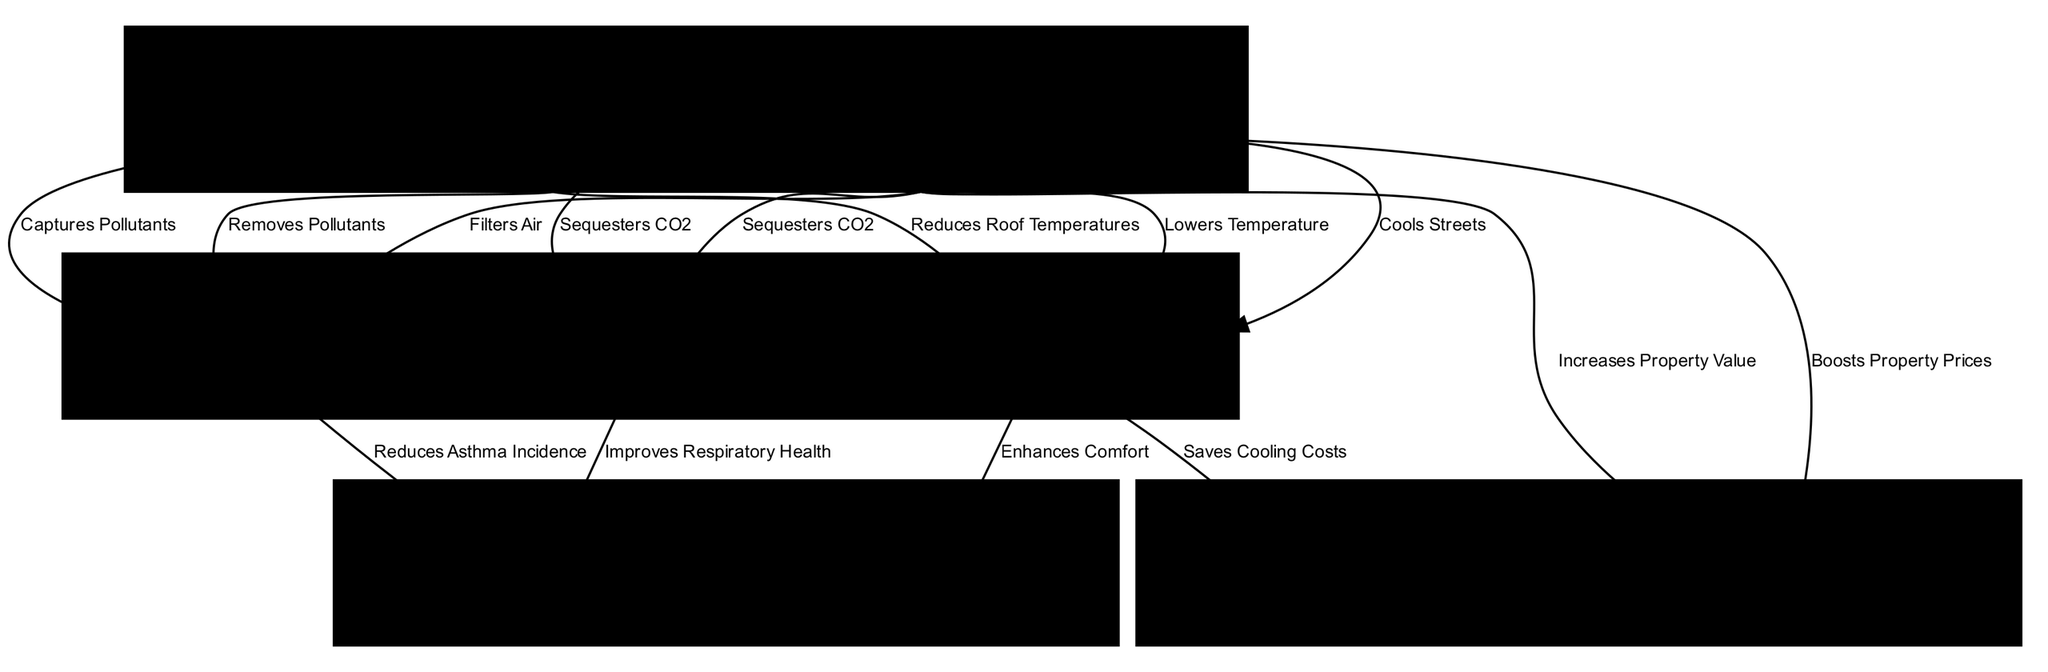What are the three types of green infrastructure elements listed? The diagram shows three types of green infrastructure elements: Urban Parks, Green Roofs, and Street Trees. This can be found in the "Green Infrastructure Elements" layer, where each element is represented as a node.
Answer: Urban Parks, Green Roofs, Street Trees How many environmental benefits are identified in the diagram? There are three environmental benefits detailed in the "Environmental Benefits" layer: CO2 Sequestration, Air Pollutant Removal, and Urban Heat Island Mitigation. Counting each node in this layer confirms the total.
Answer: Three Which green infrastructure element is associated with improving respiratory health? The Urban Parks node has a direct edge to the Respiratory Health node, indicating it contributes to improving respiratory health. By examining the connections between nodes, we identify this relationship.
Answer: Urban Parks What type of health impact is improved by mitigating urban heat islands? From the diagram, the Urban Heat Island Mitigation node connects to the Mental Well-being node, indicating that it enhances comfort, leading to improvements in mental health. This requires understanding the relationship between these two nodes.
Answer: Mental Well-being How many edges connect green infrastructure elements to environmental benefits? There are six edges connecting the green infrastructure elements to environmental benefits, as we can count the number of edges originating from the nodes in the "Green Infrastructure Elements" layer and leading to the "Environmental Benefits" layer.
Answer: Six Which green infrastructure element increases property values? Both the Urban Parks and Street Trees have edges pointing to the Increased Property Values node, indicating they contribute to boosting property prices. This requires looking at the edges connected to the property values node.
Answer: Urban Parks, Street Trees What is the economic benefit associated with healthcare cost savings? The Savings Cooling Costs node connects to the Healthcare Cost Savings node, indicating a relationship. This demonstrates how cost savings from reduced cooling needs might lead to lower overall healthcare expenses.
Answer: Healthcare Cost Savings What is one example of air pollutant removal mentioned in the diagram? The Air Pollutant Removal node specifically includes PM2.5, NO2, SO2 as examples of pollutants that are removed through the processes associated with green infrastructure elements. This demonstrates a direct relationship with that node.
Answer: PM2.5, NO2, SO2 